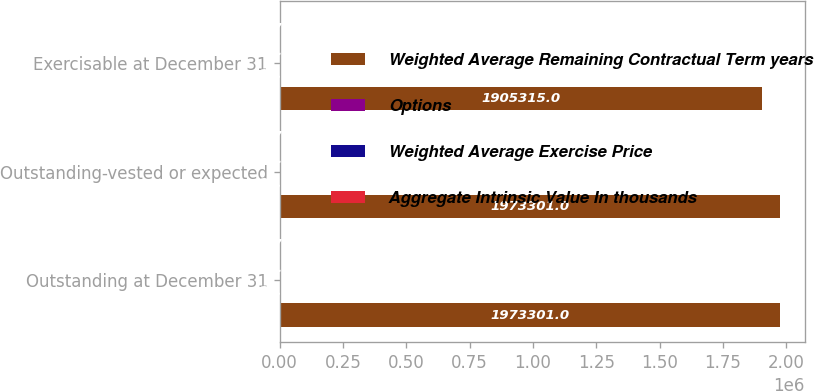Convert chart to OTSL. <chart><loc_0><loc_0><loc_500><loc_500><stacked_bar_chart><ecel><fcel>Outstanding at December 31<fcel>Outstanding-vested or expected<fcel>Exercisable at December 31<nl><fcel>Weighted Average Remaining Contractual Term years<fcel>1.9733e+06<fcel>1.9733e+06<fcel>1.90532e+06<nl><fcel>Options<fcel>20.92<fcel>20.92<fcel>20.75<nl><fcel>Weighted Average Exercise Price<fcel>3.3<fcel>3.3<fcel>3.2<nl><fcel>Aggregate Intrinsic Value In thousands<fcel>5078<fcel>5078<fcel>5078<nl></chart> 